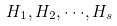<formula> <loc_0><loc_0><loc_500><loc_500>H _ { 1 } , H _ { 2 } , \cdot \cdot \cdot , H _ { s }</formula> 